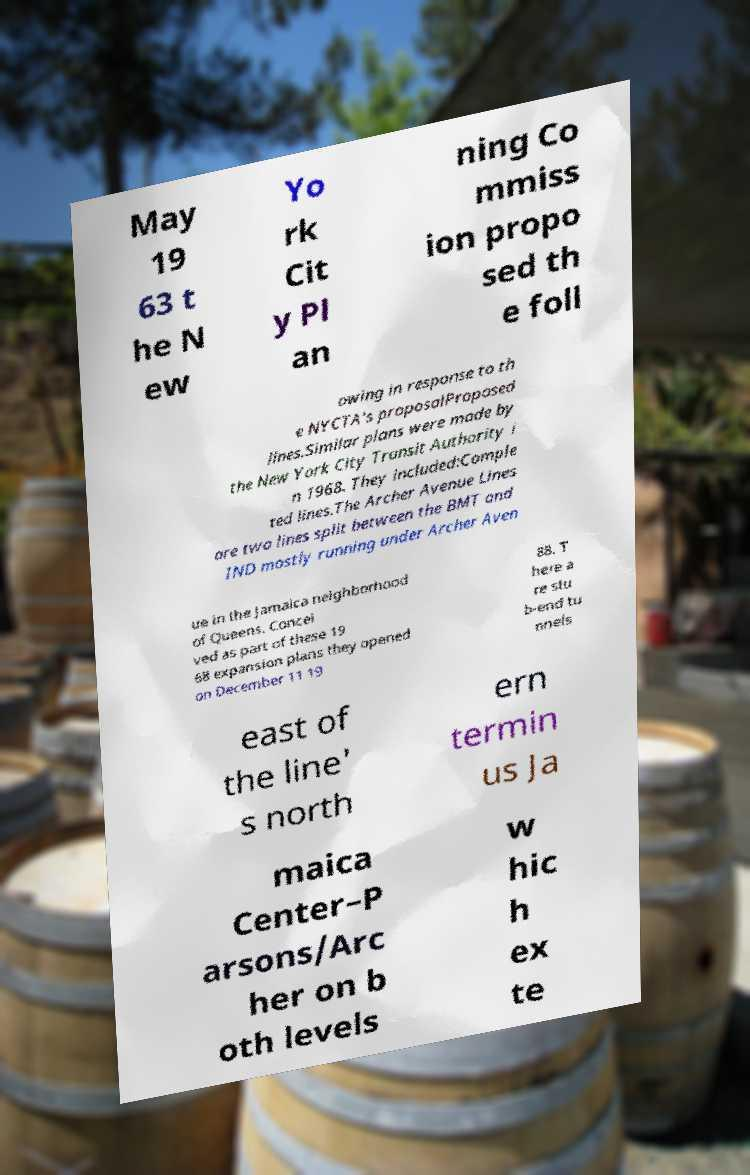Please identify and transcribe the text found in this image. May 19 63 t he N ew Yo rk Cit y Pl an ning Co mmiss ion propo sed th e foll owing in response to th e NYCTA's proposalProposed lines.Similar plans were made by the New York City Transit Authority i n 1968. They included:Comple ted lines.The Archer Avenue Lines are two lines split between the BMT and IND mostly running under Archer Aven ue in the Jamaica neighborhood of Queens. Concei ved as part of these 19 68 expansion plans they opened on December 11 19 88. T here a re stu b-end tu nnels east of the line' s north ern termin us Ja maica Center–P arsons/Arc her on b oth levels w hic h ex te 